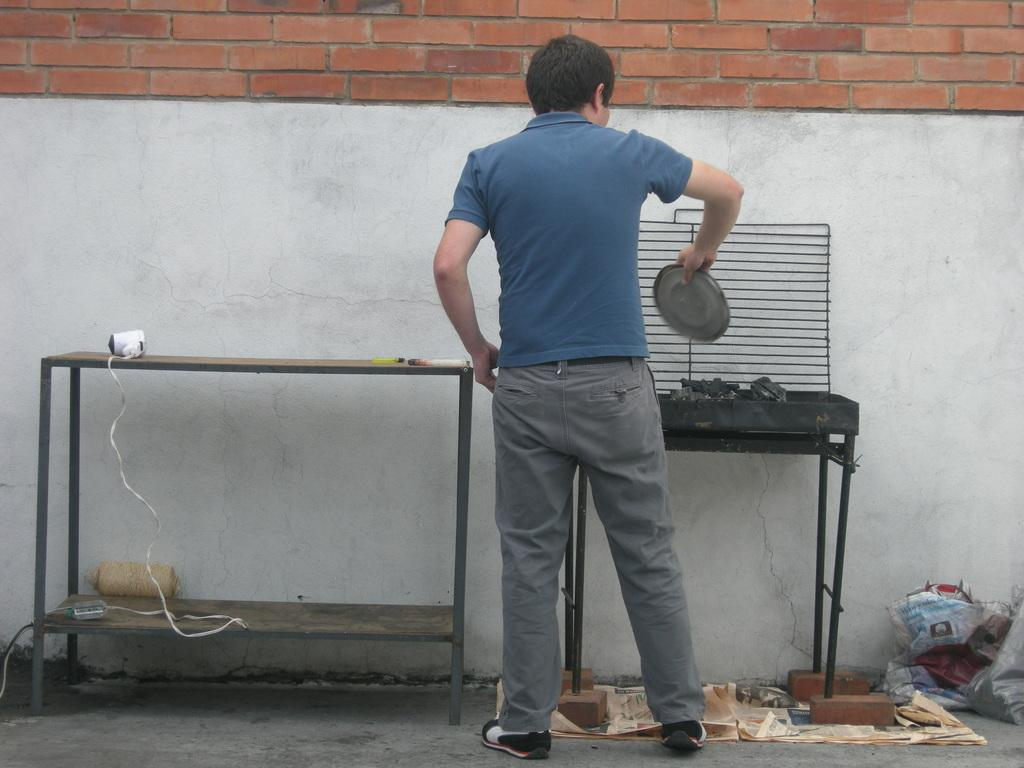What is the person in the image wearing on their upper body? The person is wearing a blue t-shirt. What type of pants is the person wearing? The person is wearing trousers. What is the person holding in their hand? The person is holding a plate in their hand. What can be seen in the image related to cooking or food preparation? There is a grill in the image. Where is the table located in the image? There is a table at the left side of the image. What is visible at the back of the image? There is a wall at the back of the image. What type of bite can be seen on the person's arm in the image? There is no bite visible on the person's arm in the image. What type of bun is the person holding on the plate in the image? The person is holding a plate, but there is no mention of a bun in the image. 